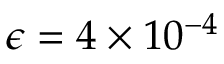Convert formula to latex. <formula><loc_0><loc_0><loc_500><loc_500>\epsilon = 4 \times 1 0 ^ { - 4 }</formula> 